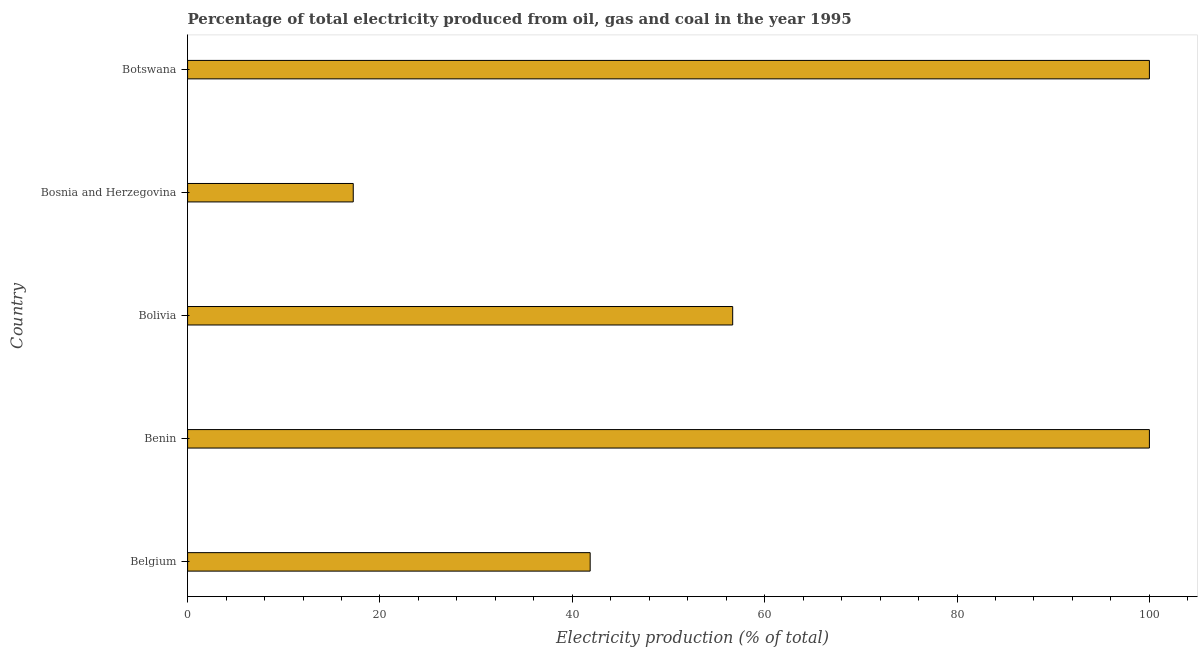What is the title of the graph?
Give a very brief answer. Percentage of total electricity produced from oil, gas and coal in the year 1995. What is the label or title of the X-axis?
Offer a very short reply. Electricity production (% of total). What is the electricity production in Bosnia and Herzegovina?
Provide a succinct answer. 17.22. Across all countries, what is the maximum electricity production?
Your answer should be compact. 100. Across all countries, what is the minimum electricity production?
Ensure brevity in your answer.  17.22. In which country was the electricity production maximum?
Your answer should be very brief. Benin. In which country was the electricity production minimum?
Your answer should be compact. Bosnia and Herzegovina. What is the sum of the electricity production?
Ensure brevity in your answer.  315.75. What is the difference between the electricity production in Benin and Botswana?
Keep it short and to the point. 0. What is the average electricity production per country?
Your response must be concise. 63.15. What is the median electricity production?
Your answer should be very brief. 56.67. In how many countries, is the electricity production greater than 32 %?
Make the answer very short. 4. What is the ratio of the electricity production in Bolivia to that in Botswana?
Make the answer very short. 0.57. Is the electricity production in Bolivia less than that in Botswana?
Your answer should be very brief. Yes. Is the difference between the electricity production in Belgium and Bosnia and Herzegovina greater than the difference between any two countries?
Make the answer very short. No. What is the difference between the highest and the second highest electricity production?
Give a very brief answer. 0. What is the difference between the highest and the lowest electricity production?
Give a very brief answer. 82.78. In how many countries, is the electricity production greater than the average electricity production taken over all countries?
Your answer should be compact. 2. Are all the bars in the graph horizontal?
Your answer should be compact. Yes. What is the Electricity production (% of total) in Belgium?
Your response must be concise. 41.86. What is the Electricity production (% of total) of Benin?
Make the answer very short. 100. What is the Electricity production (% of total) in Bolivia?
Keep it short and to the point. 56.67. What is the Electricity production (% of total) in Bosnia and Herzegovina?
Your answer should be compact. 17.22. What is the difference between the Electricity production (% of total) in Belgium and Benin?
Your answer should be compact. -58.14. What is the difference between the Electricity production (% of total) in Belgium and Bolivia?
Provide a short and direct response. -14.82. What is the difference between the Electricity production (% of total) in Belgium and Bosnia and Herzegovina?
Make the answer very short. 24.63. What is the difference between the Electricity production (% of total) in Belgium and Botswana?
Provide a succinct answer. -58.14. What is the difference between the Electricity production (% of total) in Benin and Bolivia?
Provide a succinct answer. 43.33. What is the difference between the Electricity production (% of total) in Benin and Bosnia and Herzegovina?
Offer a very short reply. 82.78. What is the difference between the Electricity production (% of total) in Benin and Botswana?
Make the answer very short. 0. What is the difference between the Electricity production (% of total) in Bolivia and Bosnia and Herzegovina?
Provide a short and direct response. 39.45. What is the difference between the Electricity production (% of total) in Bolivia and Botswana?
Offer a terse response. -43.33. What is the difference between the Electricity production (% of total) in Bosnia and Herzegovina and Botswana?
Your response must be concise. -82.78. What is the ratio of the Electricity production (% of total) in Belgium to that in Benin?
Offer a very short reply. 0.42. What is the ratio of the Electricity production (% of total) in Belgium to that in Bolivia?
Provide a succinct answer. 0.74. What is the ratio of the Electricity production (% of total) in Belgium to that in Bosnia and Herzegovina?
Keep it short and to the point. 2.43. What is the ratio of the Electricity production (% of total) in Belgium to that in Botswana?
Offer a terse response. 0.42. What is the ratio of the Electricity production (% of total) in Benin to that in Bolivia?
Offer a very short reply. 1.76. What is the ratio of the Electricity production (% of total) in Benin to that in Bosnia and Herzegovina?
Your response must be concise. 5.81. What is the ratio of the Electricity production (% of total) in Benin to that in Botswana?
Your response must be concise. 1. What is the ratio of the Electricity production (% of total) in Bolivia to that in Bosnia and Herzegovina?
Provide a short and direct response. 3.29. What is the ratio of the Electricity production (% of total) in Bolivia to that in Botswana?
Make the answer very short. 0.57. What is the ratio of the Electricity production (% of total) in Bosnia and Herzegovina to that in Botswana?
Your answer should be very brief. 0.17. 